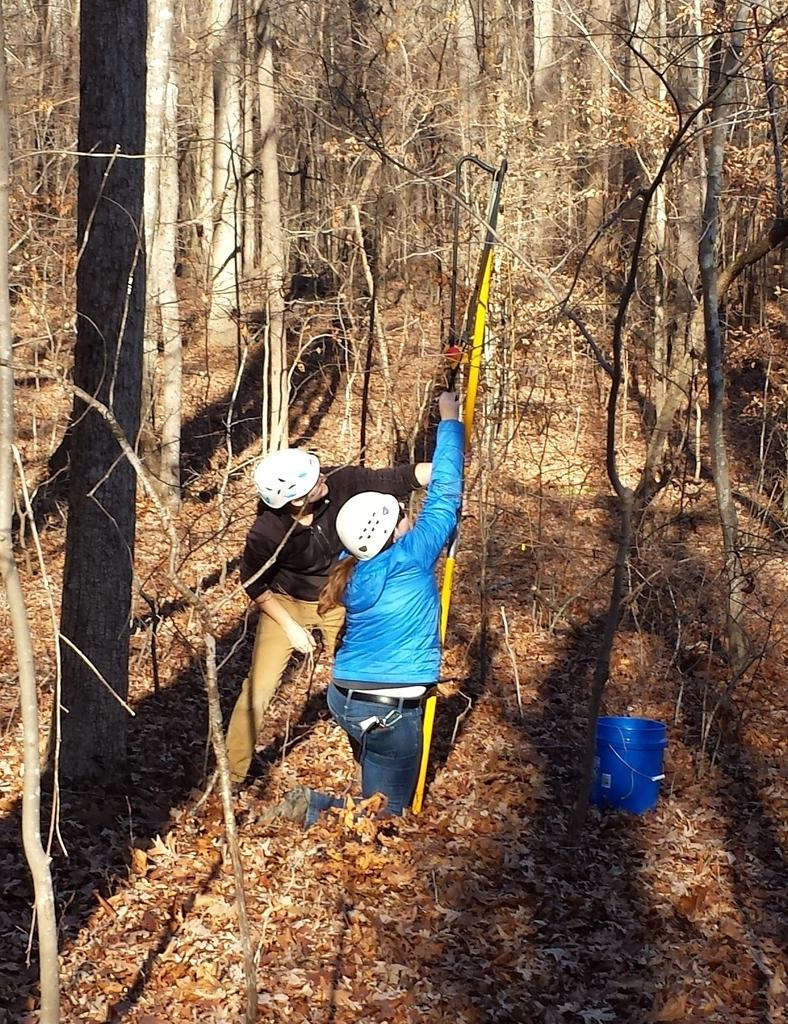What can be seen in the foreground of the picture? In the foreground of the picture, there are dry leaves, a bucket, trees, and two women. What is the primary subject of the picture? The primary subjects of the picture are the two women. What can be seen in the background of the picture? In the background of the picture, there are trees. What color is the goat in the picture? There is no goat present in the picture. Can you describe the body language of the women in the picture? The provided facts do not include information about the body language of the women in the picture. 